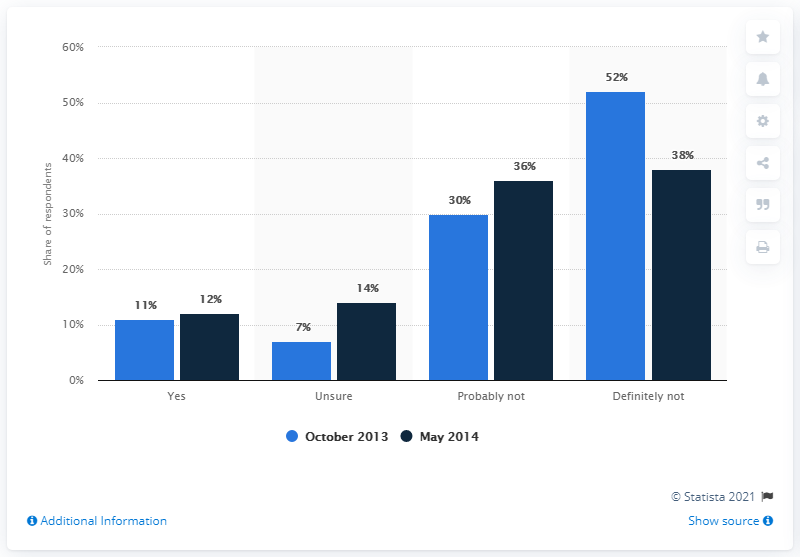Highlight a few significant elements in this photo. In the month of October 2013, customers in the UK expressed their intentions to switch banks. In October 2013, the percentage was 52%. The opinion that has doubled with time is uncertain. 